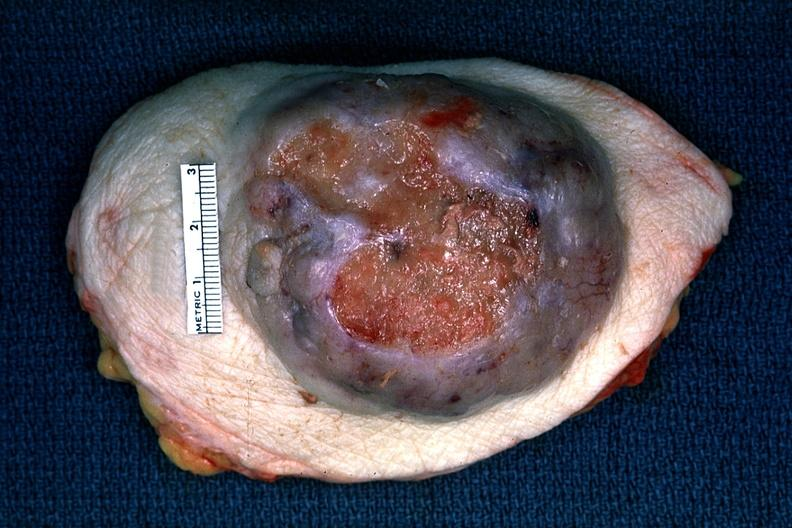s all the fat necrosis present?
Answer the question using a single word or phrase. No 